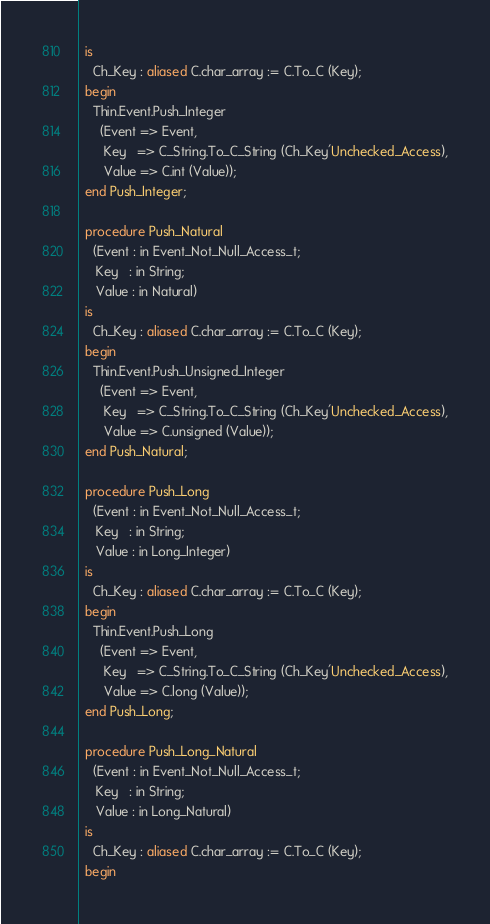Convert code to text. <code><loc_0><loc_0><loc_500><loc_500><_Ada_>  is
    Ch_Key : aliased C.char_array := C.To_C (Key);
  begin
    Thin.Event.Push_Integer
      (Event => Event,
       Key   => C_String.To_C_String (Ch_Key'Unchecked_Access),
       Value => C.int (Value));
  end Push_Integer;

  procedure Push_Natural
    (Event : in Event_Not_Null_Access_t;
     Key   : in String;
     Value : in Natural)
  is
    Ch_Key : aliased C.char_array := C.To_C (Key);
  begin
    Thin.Event.Push_Unsigned_Integer
      (Event => Event,
       Key   => C_String.To_C_String (Ch_Key'Unchecked_Access),
       Value => C.unsigned (Value));
  end Push_Natural;

  procedure Push_Long
    (Event : in Event_Not_Null_Access_t;
     Key   : in String;
     Value : in Long_Integer)
  is
    Ch_Key : aliased C.char_array := C.To_C (Key);
  begin
    Thin.Event.Push_Long
      (Event => Event,
       Key   => C_String.To_C_String (Ch_Key'Unchecked_Access),
       Value => C.long (Value));
  end Push_Long;

  procedure Push_Long_Natural
    (Event : in Event_Not_Null_Access_t;
     Key   : in String;
     Value : in Long_Natural)
  is
    Ch_Key : aliased C.char_array := C.To_C (Key);
  begin</code> 